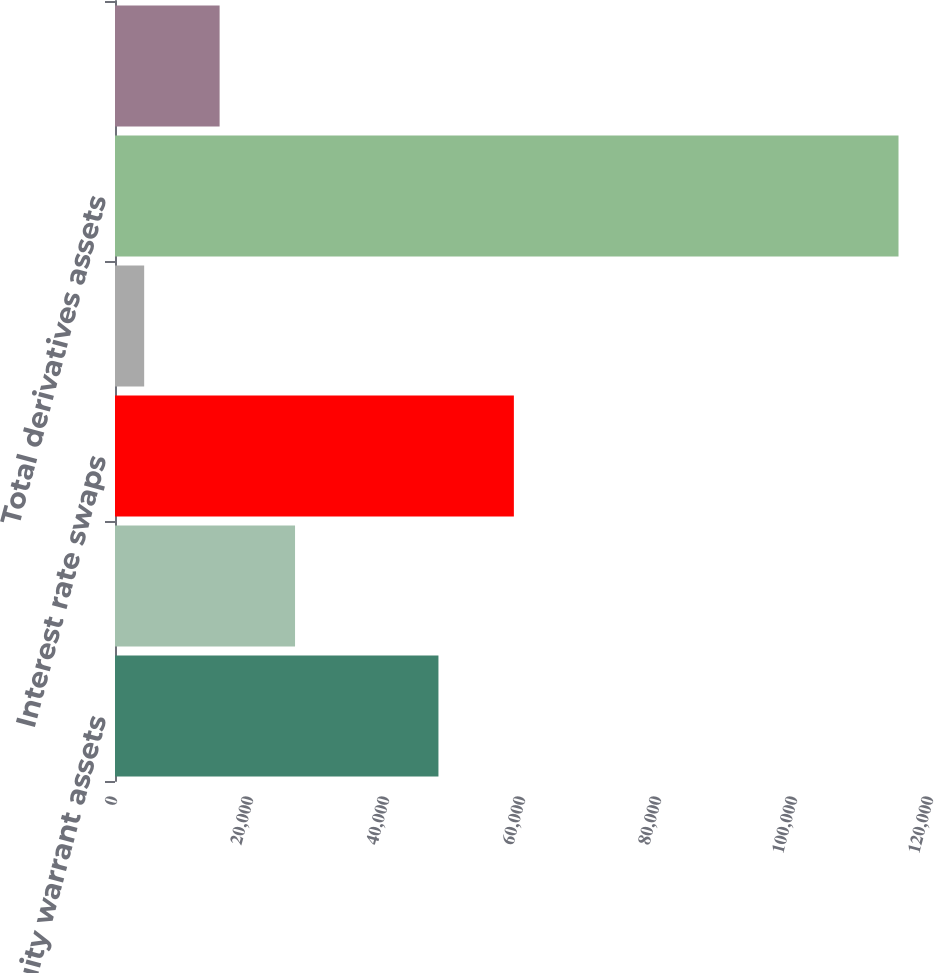Convert chart to OTSL. <chart><loc_0><loc_0><loc_500><loc_500><bar_chart><fcel>Equity warrant assets<fcel>Foreign exchange forward and<fcel>Interest rate swaps<fcel>Loan conversion options<fcel>Total derivatives assets<fcel>Total derivatives liabilities<nl><fcel>47565<fcel>26477.2<fcel>58658.1<fcel>4291<fcel>115222<fcel>15384.1<nl></chart> 